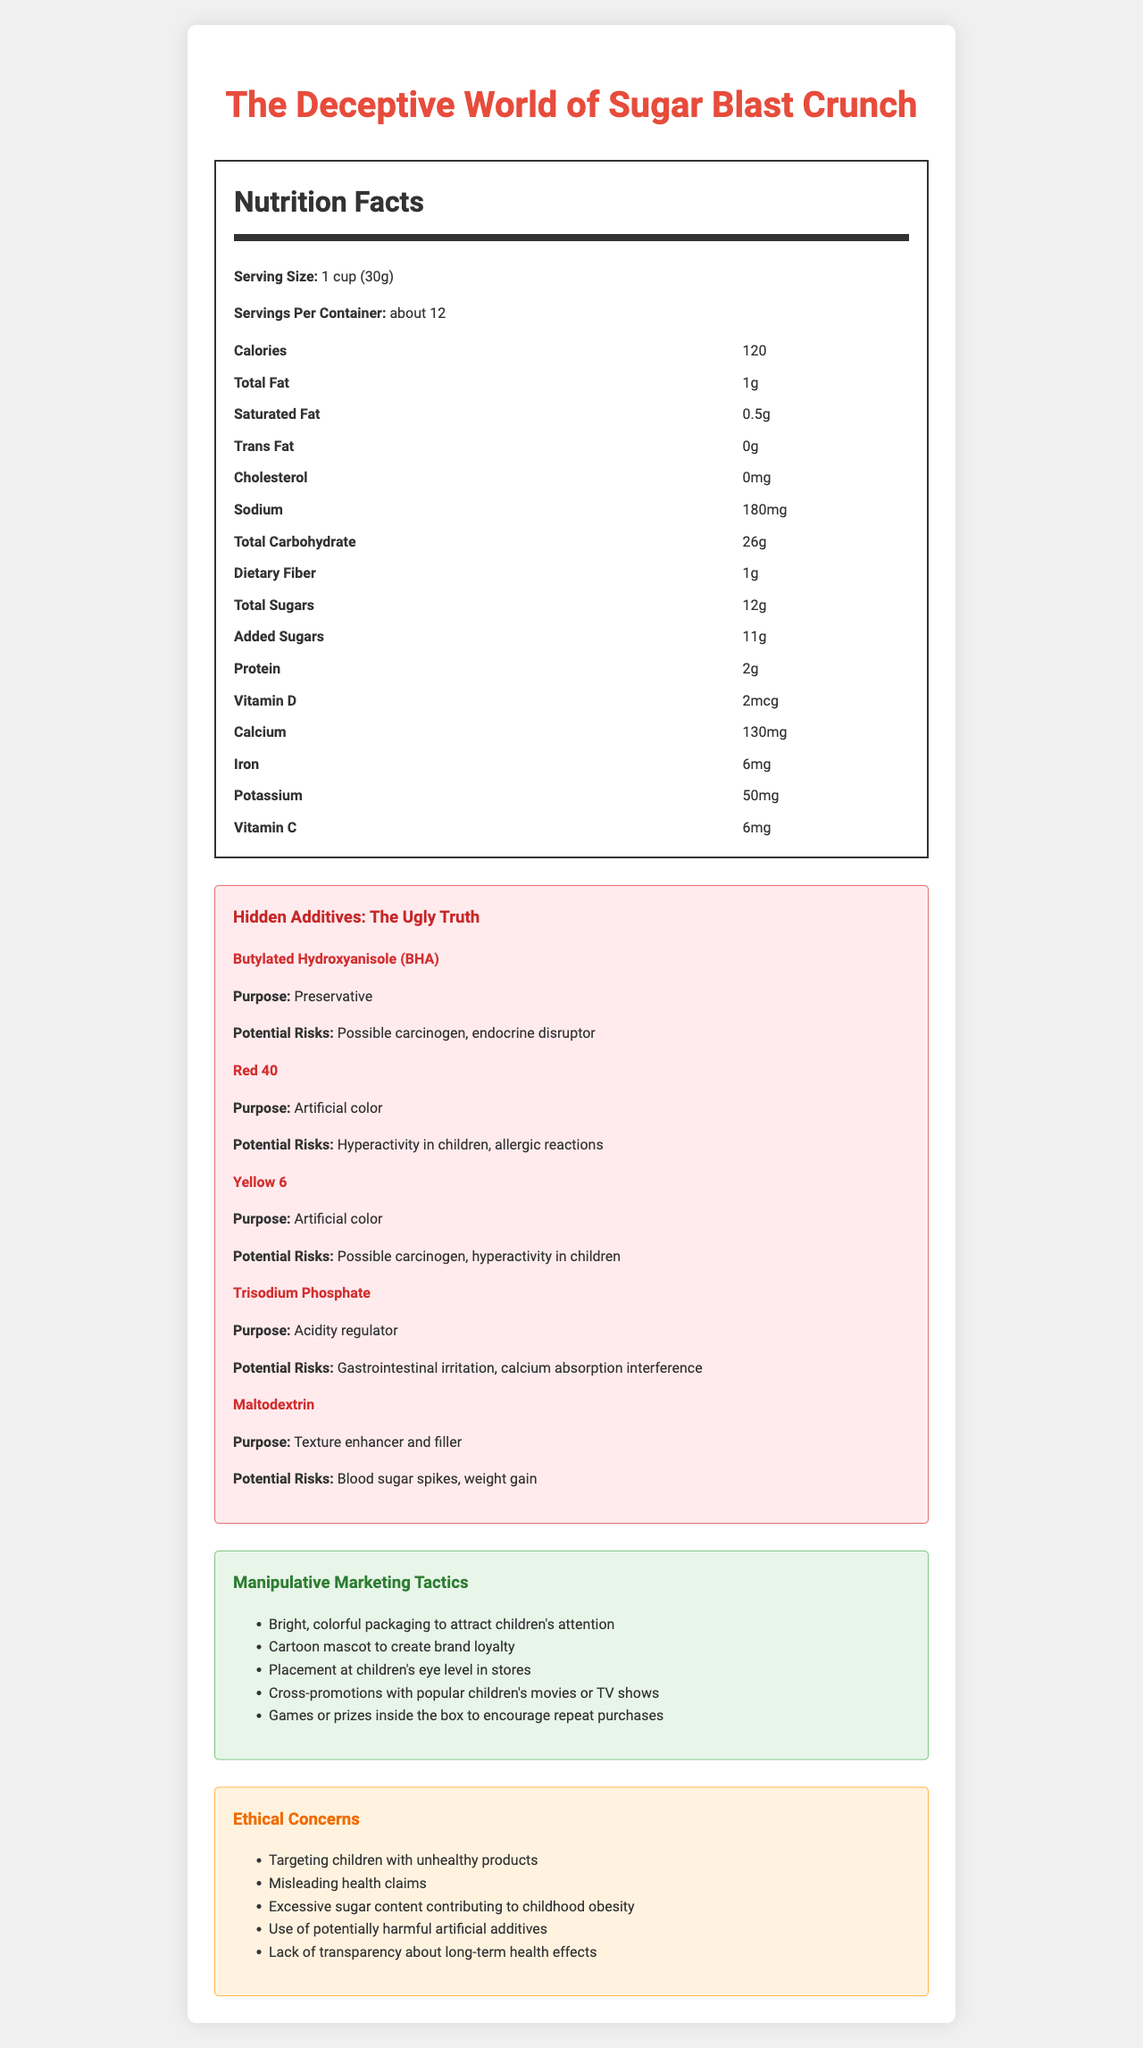how many servings are there in a container? The "Servings Per Container" is listed as "about 12" in the Nutrition Facts.
Answer: about 12 what is the purpose of Butylated Hydroxyanisole (BHA)? In the Hidden Additives section, Butylated Hydroxyanisole (BHA) is listed with a purpose of "Preservative."
Answer: Preservative how much total carbohydrate is there in one serving? The Nutrition Facts section lists the "Total Carbohydrate" as 26g per serving.
Answer: 26g name one potential risk of Trisodium Phosphate In the Hidden Additives section, under Trisodium Phosphate, "Potential Risks" are listed as "Gastrointestinal irritation, calcium absorption interference."
Answer: Gastrointestinal irritation what are the ethical concerns mentioned in the document? The Ethical Concerns section lists these issues explicitly.
Answer: Targeting children with unhealthy products, misleading health claims, excessive sugar content contributing to childhood obesity, use of potentially harmful artificial additives, lack of transparency about long-term health effects how many grams of total sugars are there per serving? The Nutrition Facts section specifies 12g for "Total Sugars."
Answer: 12g which of the following is an artificial color found in the cereal? A. BHA B. Trisodium Phosphate C. Red 40 D. Maltodextrin In the Hidden Additives section, Red 40 is listed as an artificial color, while the others listed have different purposes.
Answer: C. Red 40 which of these potential risks is NOT associated with Yellow 6? A. Possible carcinogen B. Calcium absorption interference C. Hyperactivity in children The Hidden Additives section lists possible carcinogen and hyperactivity in children as risks for Yellow 6, but calcium absorption interference is listed under Trisodium Phosphate.
Answer: B. Calcium absorption interference is the cereal cholesterol-free? The Nutritional Facts section lists cholesterol as "0mg," indicating it is cholesterol-free.
Answer: Yes summarize the main idea of the document. The document provides nutritional information, pinpoints harmful additives and risks, and discusses ethical issues and deceptive marketing practices related to the product.
Answer: The document presents a detailed analysis of the Nutrition Facts Label for the children's cereal, "Sugar Blast Crunch." It reveals hidden artificial additives and their potential risks, highlights manipulative marketing tactics used by the brand, and raises ethical concerns regarding unhealthy product targeting toward children. what percentage of the Daily Value (DV) for Vitamin D does one serving contain? The document states the amount of Vitamin D (2mcg) but does not provide the percentage of the Daily Value (%DV).
Answer: Not enough information 